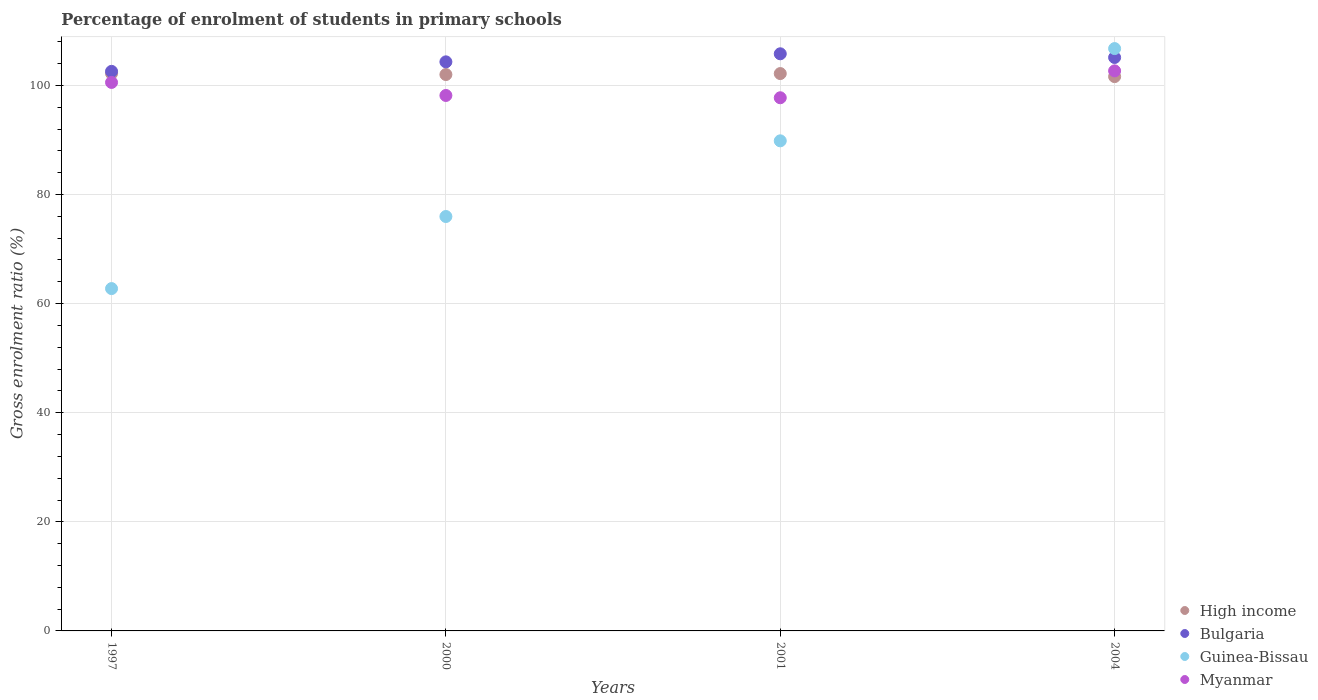Is the number of dotlines equal to the number of legend labels?
Your answer should be compact. Yes. What is the percentage of students enrolled in primary schools in Guinea-Bissau in 1997?
Make the answer very short. 62.76. Across all years, what is the maximum percentage of students enrolled in primary schools in Bulgaria?
Give a very brief answer. 105.8. Across all years, what is the minimum percentage of students enrolled in primary schools in Guinea-Bissau?
Offer a terse response. 62.76. In which year was the percentage of students enrolled in primary schools in Myanmar minimum?
Offer a very short reply. 2001. What is the total percentage of students enrolled in primary schools in Myanmar in the graph?
Provide a short and direct response. 399.11. What is the difference between the percentage of students enrolled in primary schools in Guinea-Bissau in 2001 and that in 2004?
Ensure brevity in your answer.  -16.91. What is the difference between the percentage of students enrolled in primary schools in Myanmar in 2001 and the percentage of students enrolled in primary schools in High income in 2000?
Give a very brief answer. -4.26. What is the average percentage of students enrolled in primary schools in High income per year?
Your answer should be compact. 101.99. In the year 2000, what is the difference between the percentage of students enrolled in primary schools in Guinea-Bissau and percentage of students enrolled in primary schools in Myanmar?
Provide a succinct answer. -22.19. In how many years, is the percentage of students enrolled in primary schools in Myanmar greater than 40 %?
Offer a terse response. 4. What is the ratio of the percentage of students enrolled in primary schools in High income in 2001 to that in 2004?
Make the answer very short. 1.01. Is the percentage of students enrolled in primary schools in Guinea-Bissau in 1997 less than that in 2001?
Your answer should be compact. Yes. Is the difference between the percentage of students enrolled in primary schools in Guinea-Bissau in 2000 and 2004 greater than the difference between the percentage of students enrolled in primary schools in Myanmar in 2000 and 2004?
Provide a succinct answer. No. What is the difference between the highest and the second highest percentage of students enrolled in primary schools in High income?
Offer a terse response. 0.02. What is the difference between the highest and the lowest percentage of students enrolled in primary schools in High income?
Give a very brief answer. 0.57. Is it the case that in every year, the sum of the percentage of students enrolled in primary schools in Myanmar and percentage of students enrolled in primary schools in Bulgaria  is greater than the sum of percentage of students enrolled in primary schools in Guinea-Bissau and percentage of students enrolled in primary schools in High income?
Offer a terse response. Yes. Does the percentage of students enrolled in primary schools in Myanmar monotonically increase over the years?
Provide a succinct answer. No. Are the values on the major ticks of Y-axis written in scientific E-notation?
Keep it short and to the point. No. Does the graph contain any zero values?
Give a very brief answer. No. Does the graph contain grids?
Keep it short and to the point. Yes. How are the legend labels stacked?
Ensure brevity in your answer.  Vertical. What is the title of the graph?
Offer a very short reply. Percentage of enrolment of students in primary schools. What is the label or title of the X-axis?
Provide a short and direct response. Years. What is the Gross enrolment ratio (%) of High income in 1997?
Offer a terse response. 102.19. What is the Gross enrolment ratio (%) of Bulgaria in 1997?
Keep it short and to the point. 102.58. What is the Gross enrolment ratio (%) in Guinea-Bissau in 1997?
Offer a terse response. 62.76. What is the Gross enrolment ratio (%) in Myanmar in 1997?
Ensure brevity in your answer.  100.55. What is the Gross enrolment ratio (%) of High income in 2000?
Provide a succinct answer. 102. What is the Gross enrolment ratio (%) of Bulgaria in 2000?
Your answer should be compact. 104.32. What is the Gross enrolment ratio (%) of Guinea-Bissau in 2000?
Give a very brief answer. 75.97. What is the Gross enrolment ratio (%) of Myanmar in 2000?
Keep it short and to the point. 98.16. What is the Gross enrolment ratio (%) of High income in 2001?
Provide a short and direct response. 102.17. What is the Gross enrolment ratio (%) of Bulgaria in 2001?
Keep it short and to the point. 105.8. What is the Gross enrolment ratio (%) of Guinea-Bissau in 2001?
Your answer should be compact. 89.84. What is the Gross enrolment ratio (%) of Myanmar in 2001?
Keep it short and to the point. 97.74. What is the Gross enrolment ratio (%) in High income in 2004?
Your response must be concise. 101.62. What is the Gross enrolment ratio (%) in Bulgaria in 2004?
Ensure brevity in your answer.  105.12. What is the Gross enrolment ratio (%) of Guinea-Bissau in 2004?
Your response must be concise. 106.76. What is the Gross enrolment ratio (%) in Myanmar in 2004?
Make the answer very short. 102.67. Across all years, what is the maximum Gross enrolment ratio (%) in High income?
Make the answer very short. 102.19. Across all years, what is the maximum Gross enrolment ratio (%) in Bulgaria?
Ensure brevity in your answer.  105.8. Across all years, what is the maximum Gross enrolment ratio (%) of Guinea-Bissau?
Offer a very short reply. 106.76. Across all years, what is the maximum Gross enrolment ratio (%) of Myanmar?
Your answer should be very brief. 102.67. Across all years, what is the minimum Gross enrolment ratio (%) in High income?
Give a very brief answer. 101.62. Across all years, what is the minimum Gross enrolment ratio (%) of Bulgaria?
Keep it short and to the point. 102.58. Across all years, what is the minimum Gross enrolment ratio (%) in Guinea-Bissau?
Offer a terse response. 62.76. Across all years, what is the minimum Gross enrolment ratio (%) in Myanmar?
Offer a very short reply. 97.74. What is the total Gross enrolment ratio (%) in High income in the graph?
Provide a short and direct response. 407.98. What is the total Gross enrolment ratio (%) of Bulgaria in the graph?
Provide a short and direct response. 417.82. What is the total Gross enrolment ratio (%) in Guinea-Bissau in the graph?
Your answer should be compact. 335.32. What is the total Gross enrolment ratio (%) of Myanmar in the graph?
Your answer should be very brief. 399.11. What is the difference between the Gross enrolment ratio (%) of High income in 1997 and that in 2000?
Ensure brevity in your answer.  0.19. What is the difference between the Gross enrolment ratio (%) in Bulgaria in 1997 and that in 2000?
Offer a terse response. -1.74. What is the difference between the Gross enrolment ratio (%) in Guinea-Bissau in 1997 and that in 2000?
Your answer should be very brief. -13.21. What is the difference between the Gross enrolment ratio (%) in Myanmar in 1997 and that in 2000?
Offer a terse response. 2.39. What is the difference between the Gross enrolment ratio (%) in High income in 1997 and that in 2001?
Your response must be concise. 0.02. What is the difference between the Gross enrolment ratio (%) of Bulgaria in 1997 and that in 2001?
Offer a very short reply. -3.22. What is the difference between the Gross enrolment ratio (%) in Guinea-Bissau in 1997 and that in 2001?
Make the answer very short. -27.09. What is the difference between the Gross enrolment ratio (%) of Myanmar in 1997 and that in 2001?
Offer a terse response. 2.81. What is the difference between the Gross enrolment ratio (%) in High income in 1997 and that in 2004?
Your answer should be compact. 0.57. What is the difference between the Gross enrolment ratio (%) of Bulgaria in 1997 and that in 2004?
Your answer should be very brief. -2.54. What is the difference between the Gross enrolment ratio (%) of Guinea-Bissau in 1997 and that in 2004?
Keep it short and to the point. -44. What is the difference between the Gross enrolment ratio (%) of Myanmar in 1997 and that in 2004?
Your answer should be very brief. -2.12. What is the difference between the Gross enrolment ratio (%) in High income in 2000 and that in 2001?
Ensure brevity in your answer.  -0.18. What is the difference between the Gross enrolment ratio (%) in Bulgaria in 2000 and that in 2001?
Ensure brevity in your answer.  -1.48. What is the difference between the Gross enrolment ratio (%) of Guinea-Bissau in 2000 and that in 2001?
Keep it short and to the point. -13.87. What is the difference between the Gross enrolment ratio (%) in Myanmar in 2000 and that in 2001?
Your response must be concise. 0.42. What is the difference between the Gross enrolment ratio (%) of High income in 2000 and that in 2004?
Offer a very short reply. 0.38. What is the difference between the Gross enrolment ratio (%) of Bulgaria in 2000 and that in 2004?
Offer a terse response. -0.8. What is the difference between the Gross enrolment ratio (%) in Guinea-Bissau in 2000 and that in 2004?
Provide a succinct answer. -30.79. What is the difference between the Gross enrolment ratio (%) of Myanmar in 2000 and that in 2004?
Give a very brief answer. -4.51. What is the difference between the Gross enrolment ratio (%) of High income in 2001 and that in 2004?
Offer a terse response. 0.56. What is the difference between the Gross enrolment ratio (%) in Bulgaria in 2001 and that in 2004?
Provide a succinct answer. 0.68. What is the difference between the Gross enrolment ratio (%) of Guinea-Bissau in 2001 and that in 2004?
Provide a short and direct response. -16.91. What is the difference between the Gross enrolment ratio (%) of Myanmar in 2001 and that in 2004?
Your answer should be very brief. -4.93. What is the difference between the Gross enrolment ratio (%) of High income in 1997 and the Gross enrolment ratio (%) of Bulgaria in 2000?
Give a very brief answer. -2.13. What is the difference between the Gross enrolment ratio (%) of High income in 1997 and the Gross enrolment ratio (%) of Guinea-Bissau in 2000?
Provide a short and direct response. 26.22. What is the difference between the Gross enrolment ratio (%) of High income in 1997 and the Gross enrolment ratio (%) of Myanmar in 2000?
Your response must be concise. 4.03. What is the difference between the Gross enrolment ratio (%) in Bulgaria in 1997 and the Gross enrolment ratio (%) in Guinea-Bissau in 2000?
Keep it short and to the point. 26.61. What is the difference between the Gross enrolment ratio (%) in Bulgaria in 1997 and the Gross enrolment ratio (%) in Myanmar in 2000?
Your answer should be compact. 4.42. What is the difference between the Gross enrolment ratio (%) in Guinea-Bissau in 1997 and the Gross enrolment ratio (%) in Myanmar in 2000?
Your answer should be very brief. -35.4. What is the difference between the Gross enrolment ratio (%) in High income in 1997 and the Gross enrolment ratio (%) in Bulgaria in 2001?
Provide a succinct answer. -3.61. What is the difference between the Gross enrolment ratio (%) in High income in 1997 and the Gross enrolment ratio (%) in Guinea-Bissau in 2001?
Offer a terse response. 12.35. What is the difference between the Gross enrolment ratio (%) in High income in 1997 and the Gross enrolment ratio (%) in Myanmar in 2001?
Keep it short and to the point. 4.45. What is the difference between the Gross enrolment ratio (%) in Bulgaria in 1997 and the Gross enrolment ratio (%) in Guinea-Bissau in 2001?
Give a very brief answer. 12.74. What is the difference between the Gross enrolment ratio (%) of Bulgaria in 1997 and the Gross enrolment ratio (%) of Myanmar in 2001?
Offer a very short reply. 4.84. What is the difference between the Gross enrolment ratio (%) of Guinea-Bissau in 1997 and the Gross enrolment ratio (%) of Myanmar in 2001?
Give a very brief answer. -34.98. What is the difference between the Gross enrolment ratio (%) of High income in 1997 and the Gross enrolment ratio (%) of Bulgaria in 2004?
Ensure brevity in your answer.  -2.93. What is the difference between the Gross enrolment ratio (%) in High income in 1997 and the Gross enrolment ratio (%) in Guinea-Bissau in 2004?
Offer a very short reply. -4.57. What is the difference between the Gross enrolment ratio (%) of High income in 1997 and the Gross enrolment ratio (%) of Myanmar in 2004?
Provide a short and direct response. -0.48. What is the difference between the Gross enrolment ratio (%) in Bulgaria in 1997 and the Gross enrolment ratio (%) in Guinea-Bissau in 2004?
Your answer should be very brief. -4.18. What is the difference between the Gross enrolment ratio (%) in Bulgaria in 1997 and the Gross enrolment ratio (%) in Myanmar in 2004?
Provide a succinct answer. -0.09. What is the difference between the Gross enrolment ratio (%) of Guinea-Bissau in 1997 and the Gross enrolment ratio (%) of Myanmar in 2004?
Provide a succinct answer. -39.91. What is the difference between the Gross enrolment ratio (%) in High income in 2000 and the Gross enrolment ratio (%) in Bulgaria in 2001?
Make the answer very short. -3.8. What is the difference between the Gross enrolment ratio (%) of High income in 2000 and the Gross enrolment ratio (%) of Guinea-Bissau in 2001?
Keep it short and to the point. 12.15. What is the difference between the Gross enrolment ratio (%) in High income in 2000 and the Gross enrolment ratio (%) in Myanmar in 2001?
Your answer should be very brief. 4.26. What is the difference between the Gross enrolment ratio (%) of Bulgaria in 2000 and the Gross enrolment ratio (%) of Guinea-Bissau in 2001?
Give a very brief answer. 14.48. What is the difference between the Gross enrolment ratio (%) in Bulgaria in 2000 and the Gross enrolment ratio (%) in Myanmar in 2001?
Make the answer very short. 6.58. What is the difference between the Gross enrolment ratio (%) in Guinea-Bissau in 2000 and the Gross enrolment ratio (%) in Myanmar in 2001?
Provide a short and direct response. -21.77. What is the difference between the Gross enrolment ratio (%) of High income in 2000 and the Gross enrolment ratio (%) of Bulgaria in 2004?
Your answer should be compact. -3.13. What is the difference between the Gross enrolment ratio (%) in High income in 2000 and the Gross enrolment ratio (%) in Guinea-Bissau in 2004?
Offer a terse response. -4.76. What is the difference between the Gross enrolment ratio (%) of High income in 2000 and the Gross enrolment ratio (%) of Myanmar in 2004?
Keep it short and to the point. -0.67. What is the difference between the Gross enrolment ratio (%) in Bulgaria in 2000 and the Gross enrolment ratio (%) in Guinea-Bissau in 2004?
Your answer should be very brief. -2.43. What is the difference between the Gross enrolment ratio (%) in Bulgaria in 2000 and the Gross enrolment ratio (%) in Myanmar in 2004?
Offer a very short reply. 1.65. What is the difference between the Gross enrolment ratio (%) in Guinea-Bissau in 2000 and the Gross enrolment ratio (%) in Myanmar in 2004?
Your answer should be very brief. -26.7. What is the difference between the Gross enrolment ratio (%) in High income in 2001 and the Gross enrolment ratio (%) in Bulgaria in 2004?
Provide a succinct answer. -2.95. What is the difference between the Gross enrolment ratio (%) of High income in 2001 and the Gross enrolment ratio (%) of Guinea-Bissau in 2004?
Ensure brevity in your answer.  -4.58. What is the difference between the Gross enrolment ratio (%) of High income in 2001 and the Gross enrolment ratio (%) of Myanmar in 2004?
Keep it short and to the point. -0.49. What is the difference between the Gross enrolment ratio (%) of Bulgaria in 2001 and the Gross enrolment ratio (%) of Guinea-Bissau in 2004?
Provide a succinct answer. -0.96. What is the difference between the Gross enrolment ratio (%) in Bulgaria in 2001 and the Gross enrolment ratio (%) in Myanmar in 2004?
Your response must be concise. 3.13. What is the difference between the Gross enrolment ratio (%) in Guinea-Bissau in 2001 and the Gross enrolment ratio (%) in Myanmar in 2004?
Provide a succinct answer. -12.82. What is the average Gross enrolment ratio (%) in High income per year?
Your response must be concise. 101.99. What is the average Gross enrolment ratio (%) of Bulgaria per year?
Give a very brief answer. 104.46. What is the average Gross enrolment ratio (%) in Guinea-Bissau per year?
Your response must be concise. 83.83. What is the average Gross enrolment ratio (%) in Myanmar per year?
Give a very brief answer. 99.78. In the year 1997, what is the difference between the Gross enrolment ratio (%) in High income and Gross enrolment ratio (%) in Bulgaria?
Ensure brevity in your answer.  -0.39. In the year 1997, what is the difference between the Gross enrolment ratio (%) of High income and Gross enrolment ratio (%) of Guinea-Bissau?
Provide a succinct answer. 39.43. In the year 1997, what is the difference between the Gross enrolment ratio (%) in High income and Gross enrolment ratio (%) in Myanmar?
Ensure brevity in your answer.  1.64. In the year 1997, what is the difference between the Gross enrolment ratio (%) of Bulgaria and Gross enrolment ratio (%) of Guinea-Bissau?
Your response must be concise. 39.82. In the year 1997, what is the difference between the Gross enrolment ratio (%) of Bulgaria and Gross enrolment ratio (%) of Myanmar?
Your response must be concise. 2.03. In the year 1997, what is the difference between the Gross enrolment ratio (%) in Guinea-Bissau and Gross enrolment ratio (%) in Myanmar?
Provide a succinct answer. -37.79. In the year 2000, what is the difference between the Gross enrolment ratio (%) in High income and Gross enrolment ratio (%) in Bulgaria?
Make the answer very short. -2.33. In the year 2000, what is the difference between the Gross enrolment ratio (%) of High income and Gross enrolment ratio (%) of Guinea-Bissau?
Your response must be concise. 26.03. In the year 2000, what is the difference between the Gross enrolment ratio (%) in High income and Gross enrolment ratio (%) in Myanmar?
Make the answer very short. 3.84. In the year 2000, what is the difference between the Gross enrolment ratio (%) of Bulgaria and Gross enrolment ratio (%) of Guinea-Bissau?
Offer a very short reply. 28.35. In the year 2000, what is the difference between the Gross enrolment ratio (%) in Bulgaria and Gross enrolment ratio (%) in Myanmar?
Ensure brevity in your answer.  6.16. In the year 2000, what is the difference between the Gross enrolment ratio (%) of Guinea-Bissau and Gross enrolment ratio (%) of Myanmar?
Offer a very short reply. -22.19. In the year 2001, what is the difference between the Gross enrolment ratio (%) of High income and Gross enrolment ratio (%) of Bulgaria?
Give a very brief answer. -3.63. In the year 2001, what is the difference between the Gross enrolment ratio (%) of High income and Gross enrolment ratio (%) of Guinea-Bissau?
Provide a short and direct response. 12.33. In the year 2001, what is the difference between the Gross enrolment ratio (%) in High income and Gross enrolment ratio (%) in Myanmar?
Your response must be concise. 4.43. In the year 2001, what is the difference between the Gross enrolment ratio (%) in Bulgaria and Gross enrolment ratio (%) in Guinea-Bissau?
Provide a succinct answer. 15.96. In the year 2001, what is the difference between the Gross enrolment ratio (%) in Bulgaria and Gross enrolment ratio (%) in Myanmar?
Your answer should be compact. 8.06. In the year 2001, what is the difference between the Gross enrolment ratio (%) of Guinea-Bissau and Gross enrolment ratio (%) of Myanmar?
Your answer should be very brief. -7.9. In the year 2004, what is the difference between the Gross enrolment ratio (%) of High income and Gross enrolment ratio (%) of Bulgaria?
Your response must be concise. -3.51. In the year 2004, what is the difference between the Gross enrolment ratio (%) of High income and Gross enrolment ratio (%) of Guinea-Bissau?
Ensure brevity in your answer.  -5.14. In the year 2004, what is the difference between the Gross enrolment ratio (%) in High income and Gross enrolment ratio (%) in Myanmar?
Give a very brief answer. -1.05. In the year 2004, what is the difference between the Gross enrolment ratio (%) in Bulgaria and Gross enrolment ratio (%) in Guinea-Bissau?
Provide a succinct answer. -1.63. In the year 2004, what is the difference between the Gross enrolment ratio (%) in Bulgaria and Gross enrolment ratio (%) in Myanmar?
Keep it short and to the point. 2.46. In the year 2004, what is the difference between the Gross enrolment ratio (%) in Guinea-Bissau and Gross enrolment ratio (%) in Myanmar?
Provide a short and direct response. 4.09. What is the ratio of the Gross enrolment ratio (%) in High income in 1997 to that in 2000?
Provide a short and direct response. 1. What is the ratio of the Gross enrolment ratio (%) of Bulgaria in 1997 to that in 2000?
Provide a short and direct response. 0.98. What is the ratio of the Gross enrolment ratio (%) of Guinea-Bissau in 1997 to that in 2000?
Offer a very short reply. 0.83. What is the ratio of the Gross enrolment ratio (%) in Myanmar in 1997 to that in 2000?
Offer a terse response. 1.02. What is the ratio of the Gross enrolment ratio (%) of Bulgaria in 1997 to that in 2001?
Offer a very short reply. 0.97. What is the ratio of the Gross enrolment ratio (%) of Guinea-Bissau in 1997 to that in 2001?
Offer a very short reply. 0.7. What is the ratio of the Gross enrolment ratio (%) in Myanmar in 1997 to that in 2001?
Keep it short and to the point. 1.03. What is the ratio of the Gross enrolment ratio (%) of High income in 1997 to that in 2004?
Make the answer very short. 1.01. What is the ratio of the Gross enrolment ratio (%) of Bulgaria in 1997 to that in 2004?
Provide a short and direct response. 0.98. What is the ratio of the Gross enrolment ratio (%) in Guinea-Bissau in 1997 to that in 2004?
Offer a very short reply. 0.59. What is the ratio of the Gross enrolment ratio (%) in Myanmar in 1997 to that in 2004?
Your response must be concise. 0.98. What is the ratio of the Gross enrolment ratio (%) in Guinea-Bissau in 2000 to that in 2001?
Offer a very short reply. 0.85. What is the ratio of the Gross enrolment ratio (%) of Myanmar in 2000 to that in 2001?
Give a very brief answer. 1. What is the ratio of the Gross enrolment ratio (%) of Bulgaria in 2000 to that in 2004?
Ensure brevity in your answer.  0.99. What is the ratio of the Gross enrolment ratio (%) in Guinea-Bissau in 2000 to that in 2004?
Make the answer very short. 0.71. What is the ratio of the Gross enrolment ratio (%) in Myanmar in 2000 to that in 2004?
Offer a terse response. 0.96. What is the ratio of the Gross enrolment ratio (%) of High income in 2001 to that in 2004?
Provide a short and direct response. 1.01. What is the ratio of the Gross enrolment ratio (%) of Bulgaria in 2001 to that in 2004?
Your answer should be compact. 1.01. What is the ratio of the Gross enrolment ratio (%) in Guinea-Bissau in 2001 to that in 2004?
Ensure brevity in your answer.  0.84. What is the difference between the highest and the second highest Gross enrolment ratio (%) of High income?
Offer a terse response. 0.02. What is the difference between the highest and the second highest Gross enrolment ratio (%) of Bulgaria?
Make the answer very short. 0.68. What is the difference between the highest and the second highest Gross enrolment ratio (%) of Guinea-Bissau?
Your response must be concise. 16.91. What is the difference between the highest and the second highest Gross enrolment ratio (%) in Myanmar?
Your answer should be very brief. 2.12. What is the difference between the highest and the lowest Gross enrolment ratio (%) in High income?
Keep it short and to the point. 0.57. What is the difference between the highest and the lowest Gross enrolment ratio (%) in Bulgaria?
Offer a terse response. 3.22. What is the difference between the highest and the lowest Gross enrolment ratio (%) in Guinea-Bissau?
Keep it short and to the point. 44. What is the difference between the highest and the lowest Gross enrolment ratio (%) in Myanmar?
Make the answer very short. 4.93. 